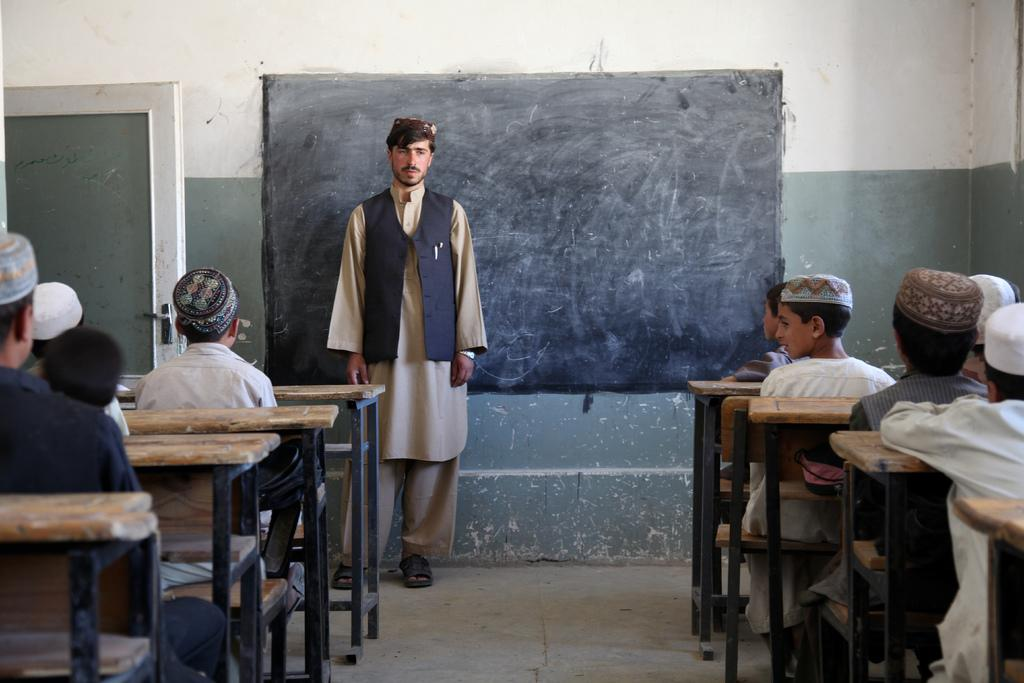Who is present in the image? There are kids and a man in the image. What are the kids doing in the image? The kids are sitting on a bench. Where is the man located in the image? The man is standing near a blackboard. What type of toothbrush is the man using to write on the blackboard? There is no toothbrush present in the image, and the man is not writing on the blackboard. 